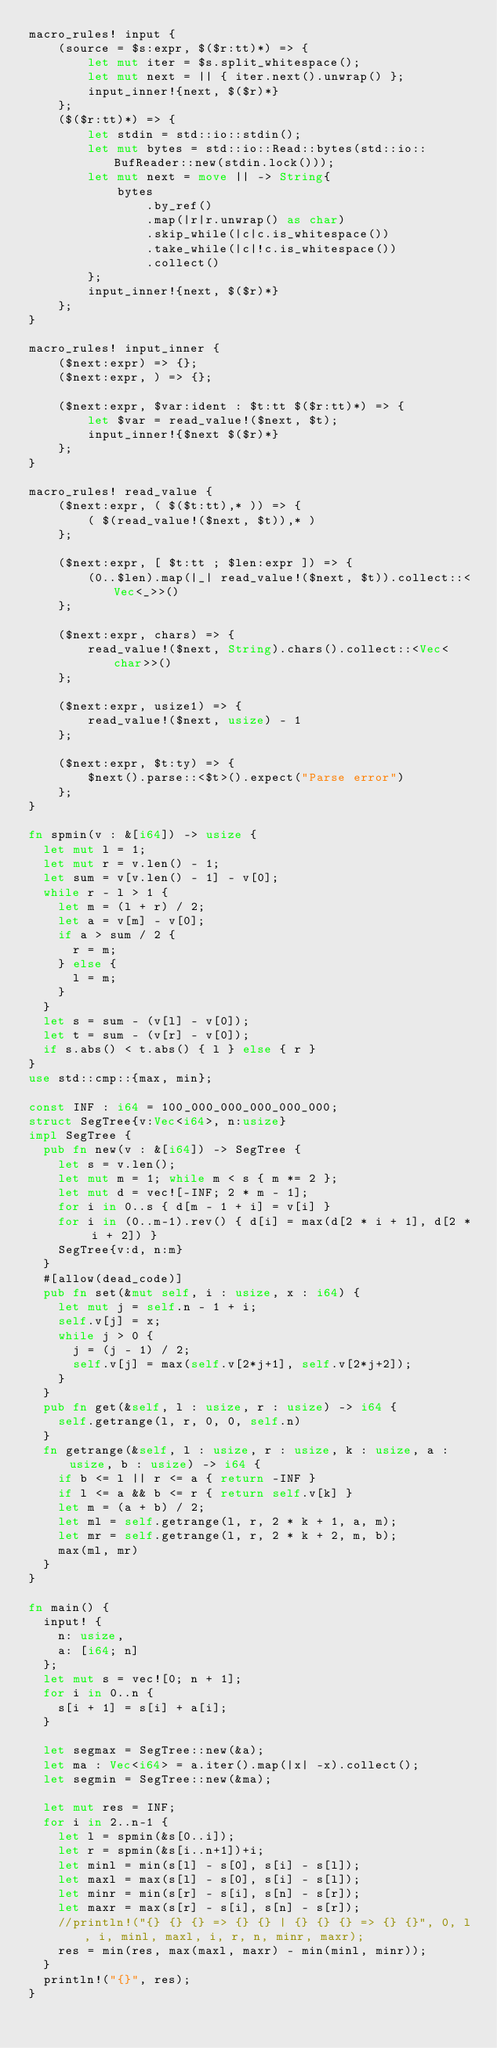<code> <loc_0><loc_0><loc_500><loc_500><_Rust_>macro_rules! input {
    (source = $s:expr, $($r:tt)*) => {
        let mut iter = $s.split_whitespace();
        let mut next = || { iter.next().unwrap() };
        input_inner!{next, $($r)*}
    };
    ($($r:tt)*) => {
        let stdin = std::io::stdin();
        let mut bytes = std::io::Read::bytes(std::io::BufReader::new(stdin.lock()));
        let mut next = move || -> String{
            bytes
                .by_ref()
                .map(|r|r.unwrap() as char)
                .skip_while(|c|c.is_whitespace())
                .take_while(|c|!c.is_whitespace())
                .collect()
        };
        input_inner!{next, $($r)*}
    };
}

macro_rules! input_inner {
    ($next:expr) => {};
    ($next:expr, ) => {};

    ($next:expr, $var:ident : $t:tt $($r:tt)*) => {
        let $var = read_value!($next, $t);
        input_inner!{$next $($r)*}
    };
}

macro_rules! read_value {
    ($next:expr, ( $($t:tt),* )) => {
        ( $(read_value!($next, $t)),* )
    };

    ($next:expr, [ $t:tt ; $len:expr ]) => {
        (0..$len).map(|_| read_value!($next, $t)).collect::<Vec<_>>()
    };

    ($next:expr, chars) => {
        read_value!($next, String).chars().collect::<Vec<char>>()
    };

    ($next:expr, usize1) => {
        read_value!($next, usize) - 1
    };

    ($next:expr, $t:ty) => {
        $next().parse::<$t>().expect("Parse error")
    };
}

fn spmin(v : &[i64]) -> usize {
  let mut l = 1;
  let mut r = v.len() - 1;
  let sum = v[v.len() - 1] - v[0];
  while r - l > 1 {
    let m = (l + r) / 2;
    let a = v[m] - v[0];
    if a > sum / 2 {
      r = m;
    } else {
      l = m;
    }
  }
  let s = sum - (v[l] - v[0]);
  let t = sum - (v[r] - v[0]);
  if s.abs() < t.abs() { l } else { r }
}
use std::cmp::{max, min};

const INF : i64 = 100_000_000_000_000_000;
struct SegTree{v:Vec<i64>, n:usize}
impl SegTree {
  pub fn new(v : &[i64]) -> SegTree {
    let s = v.len();
    let mut m = 1; while m < s { m *= 2 }; 
    let mut d = vec![-INF; 2 * m - 1];
    for i in 0..s { d[m - 1 + i] = v[i] }
    for i in (0..m-1).rev() { d[i] = max(d[2 * i + 1], d[2 * i + 2]) }
    SegTree{v:d, n:m}
  }
  #[allow(dead_code)]
  pub fn set(&mut self, i : usize, x : i64) {
    let mut j = self.n - 1 + i;
    self.v[j] = x;
    while j > 0 {
      j = (j - 1) / 2;
      self.v[j] = max(self.v[2*j+1], self.v[2*j+2]);
    }
  }
  pub fn get(&self, l : usize, r : usize) -> i64 {
    self.getrange(l, r, 0, 0, self.n) 
  }
  fn getrange(&self, l : usize, r : usize, k : usize, a : usize, b : usize) -> i64 {
    if b <= l || r <= a { return -INF }
    if l <= a && b <= r { return self.v[k] }
    let m = (a + b) / 2;
    let ml = self.getrange(l, r, 2 * k + 1, a, m);
    let mr = self.getrange(l, r, 2 * k + 2, m, b);
    max(ml, mr)
  }
}
  
fn main() {
  input! {
    n: usize,
    a: [i64; n] 
  };
  let mut s = vec![0; n + 1];
  for i in 0..n {
    s[i + 1] = s[i] + a[i];
  }
  
  let segmax = SegTree::new(&a);
  let ma : Vec<i64> = a.iter().map(|x| -x).collect();
  let segmin = SegTree::new(&ma);
  
  let mut res = INF;
  for i in 2..n-1 {
    let l = spmin(&s[0..i]);
    let r = spmin(&s[i..n+1])+i;
    let minl = min(s[l] - s[0], s[i] - s[l]);
    let maxl = max(s[l] - s[0], s[i] - s[l]);
    let minr = min(s[r] - s[i], s[n] - s[r]);
    let maxr = max(s[r] - s[i], s[n] - s[r]);
    //println!("{} {} {} => {} {} | {} {} {} => {} {}", 0, l, i, minl, maxl, i, r, n, minr, maxr);  
    res = min(res, max(maxl, maxr) - min(minl, minr));
  }
  println!("{}", res);
}</code> 